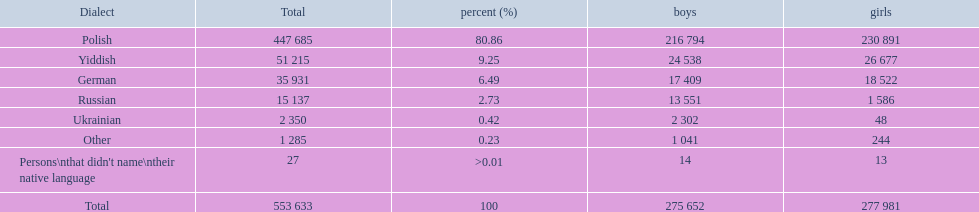What languages are there? Polish, Yiddish, German, Russian, Ukrainian. What numbers speak these languages? 447 685, 51 215, 35 931, 15 137, 2 350. What numbers are not listed as speaking these languages? 1 285, 27. What are the totals of these speakers? 553 633. 